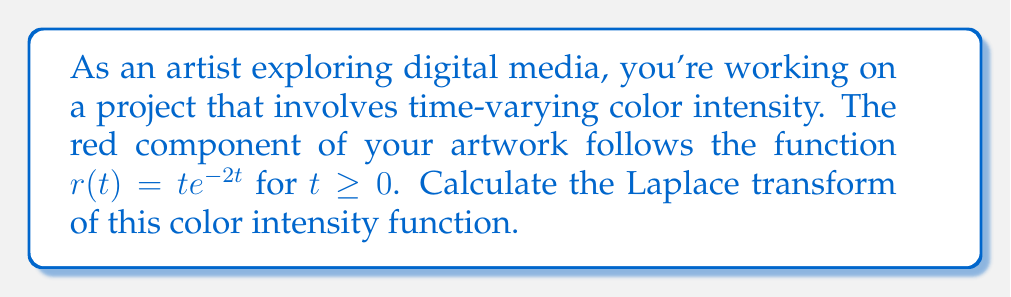Can you solve this math problem? To solve this problem, we'll follow these steps:

1) The Laplace transform of a function $f(t)$ is defined as:

   $$\mathcal{L}\{f(t)\} = F(s) = \int_0^\infty e^{-st}f(t)dt$$

2) In our case, $f(t) = te^{-2t}$, so we need to evaluate:

   $$\mathcal{L}\{te^{-2t}\} = \int_0^\infty e^{-st}te^{-2t}dt$$

3) Simplify the integrand:

   $$\int_0^\infty te^{-(s+2)t}dt$$

4) This integral can be solved using integration by parts. Let $u = t$ and $dv = e^{-(s+2)t}dt$. Then $du = dt$ and $v = -\frac{1}{s+2}e^{-(s+2)t}$.

5) Applying integration by parts:

   $$\left[-\frac{t}{s+2}e^{-(s+2)t}\right]_0^\infty + \int_0^\infty \frac{1}{s+2}e^{-(s+2)t}dt$$

6) Evaluate the first term:

   $$0 - 0 + \int_0^\infty \frac{1}{s+2}e^{-(s+2)t}dt$$

7) Solve the remaining integral:

   $$\frac{1}{s+2}\left[-\frac{1}{s+2}e^{-(s+2)t}\right]_0^\infty$$

8) Evaluate the limits:

   $$\frac{1}{s+2}\left(0 - \left(-\frac{1}{s+2}\right)\right) = \frac{1}{(s+2)^2}$$

Therefore, the Laplace transform of $te^{-2t}$ is $\frac{1}{(s+2)^2}$.
Answer: $$\mathcal{L}\{te^{-2t}\} = \frac{1}{(s+2)^2}$$ 